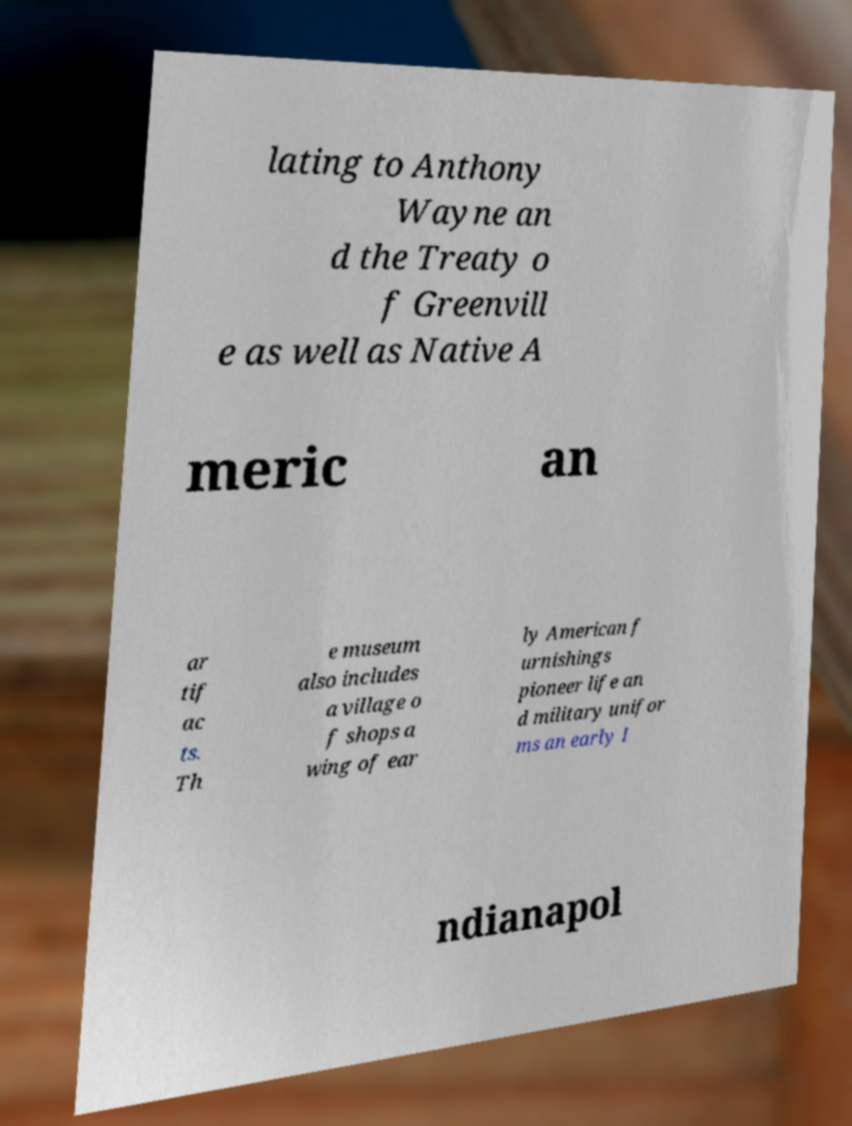What messages or text are displayed in this image? I need them in a readable, typed format. lating to Anthony Wayne an d the Treaty o f Greenvill e as well as Native A meric an ar tif ac ts. Th e museum also includes a village o f shops a wing of ear ly American f urnishings pioneer life an d military unifor ms an early I ndianapol 